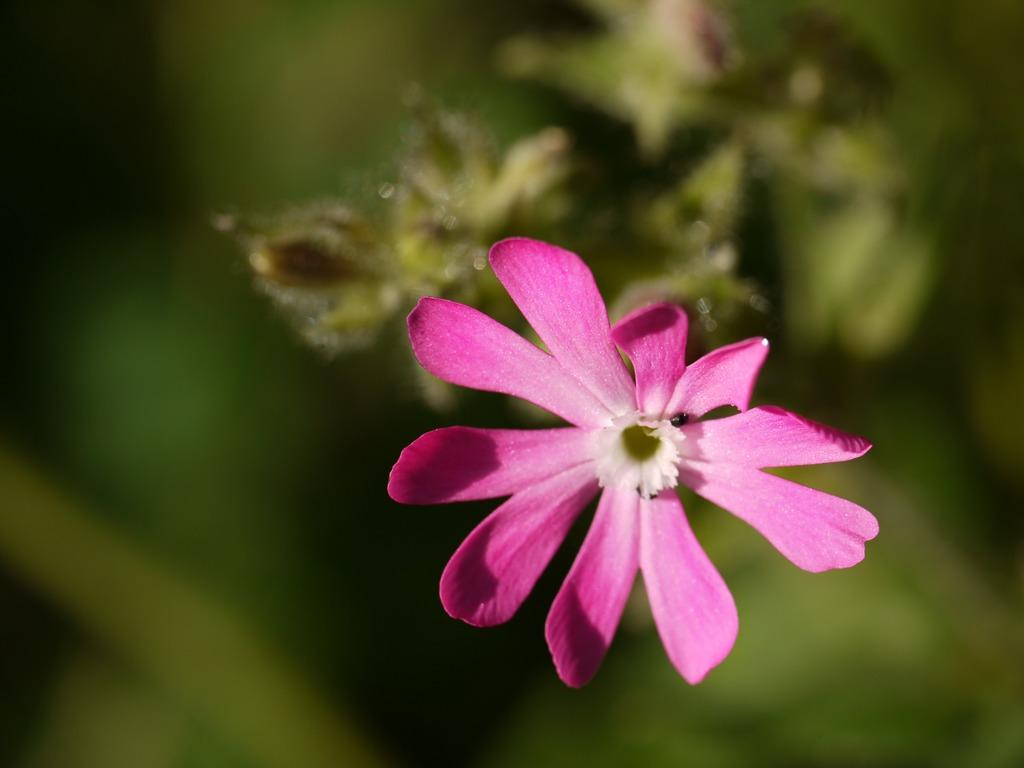What type of flower is present in the image? There is a flower in pink color in the image. What other plant-related object can be seen in the image? There is a plant in the image. Can you describe the background of the image? The background of the image is blurred. Who is the owner of the coast visible in the image? There is no coast visible in the image; it features a pink flower and a plant. What type of pest can be seen crawling on the flower in the image? There are no pests visible on the flower in the image. 